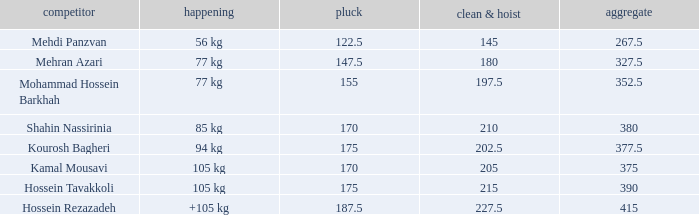Can you parse all the data within this table? {'header': ['competitor', 'happening', 'pluck', 'clean & hoist', 'aggregate'], 'rows': [['Mehdi Panzvan', '56 kg', '122.5', '145', '267.5'], ['Mehran Azari', '77 kg', '147.5', '180', '327.5'], ['Mohammad Hossein Barkhah', '77 kg', '155', '197.5', '352.5'], ['Shahin Nassirinia', '85 kg', '170', '210', '380'], ['Kourosh Bagheri', '94 kg', '175', '202.5', '377.5'], ['Kamal Mousavi', '105 kg', '170', '205', '375'], ['Hossein Tavakkoli', '105 kg', '175', '215', '390'], ['Hossein Rezazadeh', '+105 kg', '187.5', '227.5', '415']]} What event has a 122.5 snatch rate? 56 kg. 